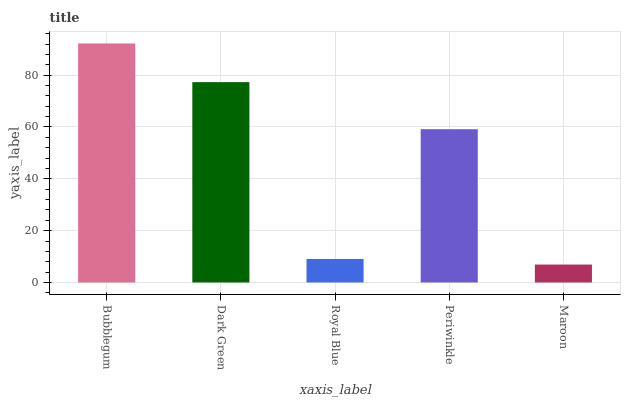Is Maroon the minimum?
Answer yes or no. Yes. Is Bubblegum the maximum?
Answer yes or no. Yes. Is Dark Green the minimum?
Answer yes or no. No. Is Dark Green the maximum?
Answer yes or no. No. Is Bubblegum greater than Dark Green?
Answer yes or no. Yes. Is Dark Green less than Bubblegum?
Answer yes or no. Yes. Is Dark Green greater than Bubblegum?
Answer yes or no. No. Is Bubblegum less than Dark Green?
Answer yes or no. No. Is Periwinkle the high median?
Answer yes or no. Yes. Is Periwinkle the low median?
Answer yes or no. Yes. Is Dark Green the high median?
Answer yes or no. No. Is Maroon the low median?
Answer yes or no. No. 